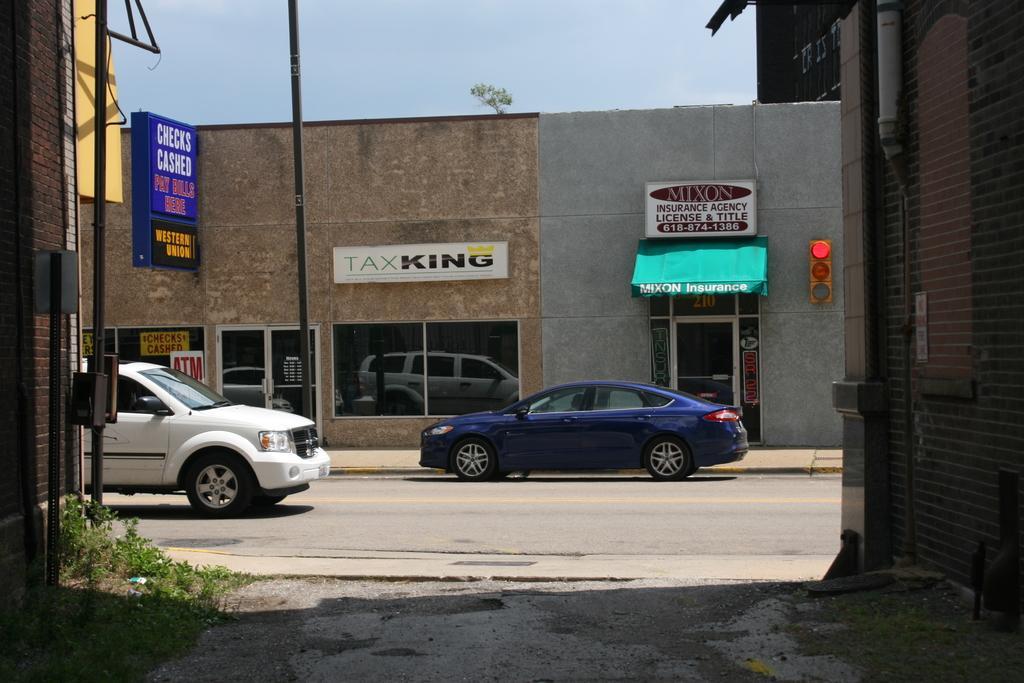Describe this image in one or two sentences. In this image I can see road, few vehicles, buildings, few boards and on these boards I can see something is written. I can also see the sky in background and here I can see signal lights. 